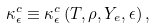<formula> <loc_0><loc_0><loc_500><loc_500>\kappa ^ { c } _ { \epsilon } \equiv \kappa ^ { c } _ { \epsilon } \left ( T , \rho , Y _ { e } , \epsilon \right ) ,</formula> 